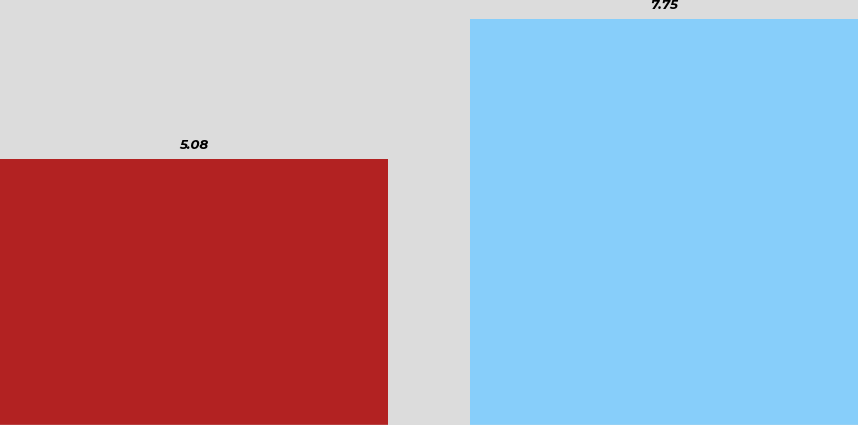<chart> <loc_0><loc_0><loc_500><loc_500><bar_chart><fcel>Discount rate<fcel>Expected return on plan assets<nl><fcel>5.08<fcel>7.75<nl></chart> 